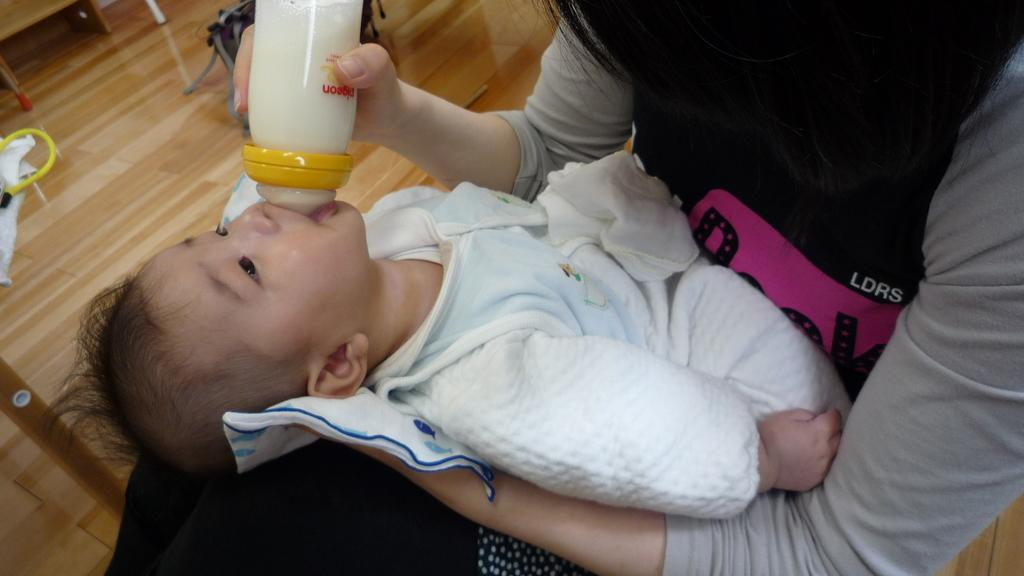What is the person in the image doing? The person is sitting and feeding a baby. How is the baby being held by the person? The person is carrying the baby in their hands. What activity is the person engaged in with the baby? The person is feeding the baby. What can be seen on the floor in the background of the image? There are objects visible on the floor in the background of the image. What type of cord is the scarecrow using to scare away birds in the image? There is no scarecrow or cord present in the image. How is the sister of the person in the image helping with the baby? There is no mention of a sister in the image or the provided facts. 